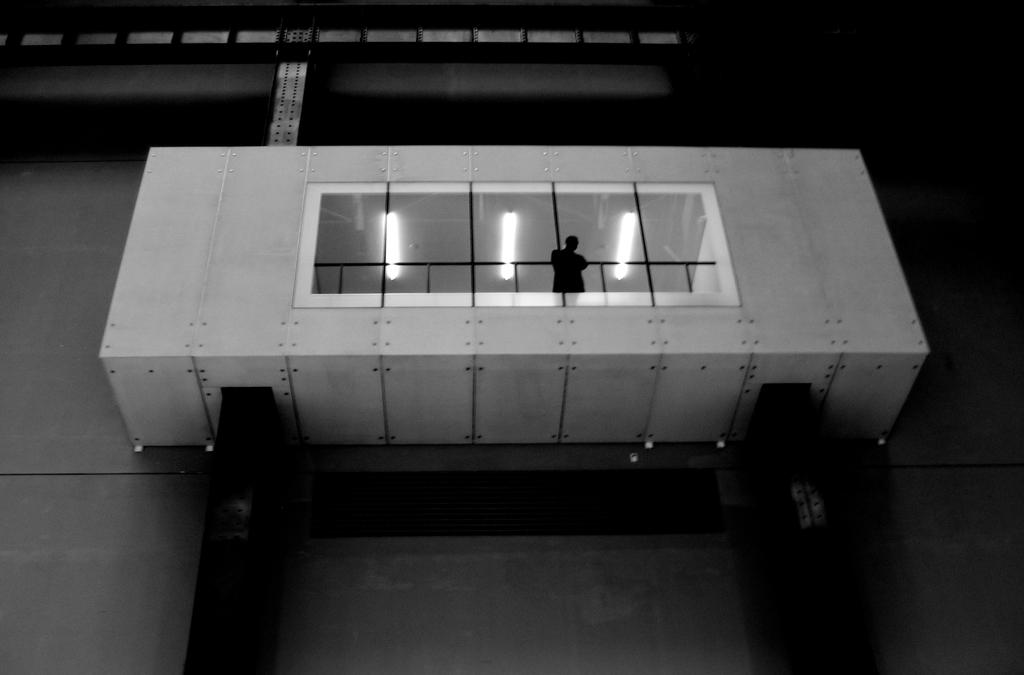What is the man in the image doing? The man is standing in the balcony in the center of the image. What can be seen in the background of the image? There are lights visible in the image. What is the main architectural feature in the image? There is a wall in the image. What force is causing the man to levitate in the image? There is no indication in the image that the man is levitating or experiencing any force. 